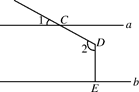In the provided diagram, let's represent angle 1 as variable u where u = 25.0 degrees. What is the degree measure of angle 2, expressed as variable v in relation to u? In order to find the degree measure for angle 2, which we'll denote as v, it's important to consider the relationships dictated by the geometry of the diagram. Angle u (25 degrees) corresponds to angle CDB due to the angles being vertically opposite when extended line through point D intersects line b. The key here is the parallelism between line a and line b, with DE being perpendicular to line b. This configuration guarantees that the angle formed at point D due to line a is a straight 90 degrees, thus angle 2 (v) is simply angle u plus these 90 degrees. Summing v = 25.0 degrees + 90 degrees results in v being 115 degrees, confirming the measure for angle 2. This understanding not only helps in solving the problem but also in visualizing the spatial relationships in parallel line configurations. 